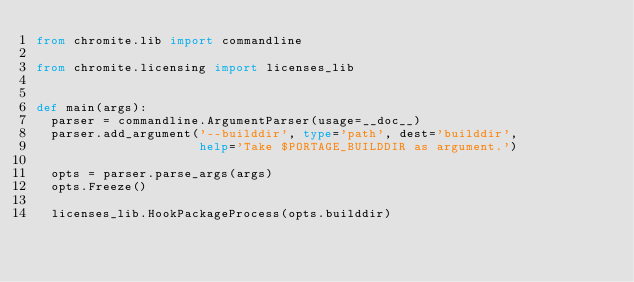<code> <loc_0><loc_0><loc_500><loc_500><_Python_>from chromite.lib import commandline

from chromite.licensing import licenses_lib


def main(args):
  parser = commandline.ArgumentParser(usage=__doc__)
  parser.add_argument('--builddir', type='path', dest='builddir',
                      help='Take $PORTAGE_BUILDDIR as argument.')

  opts = parser.parse_args(args)
  opts.Freeze()

  licenses_lib.HookPackageProcess(opts.builddir)
</code> 